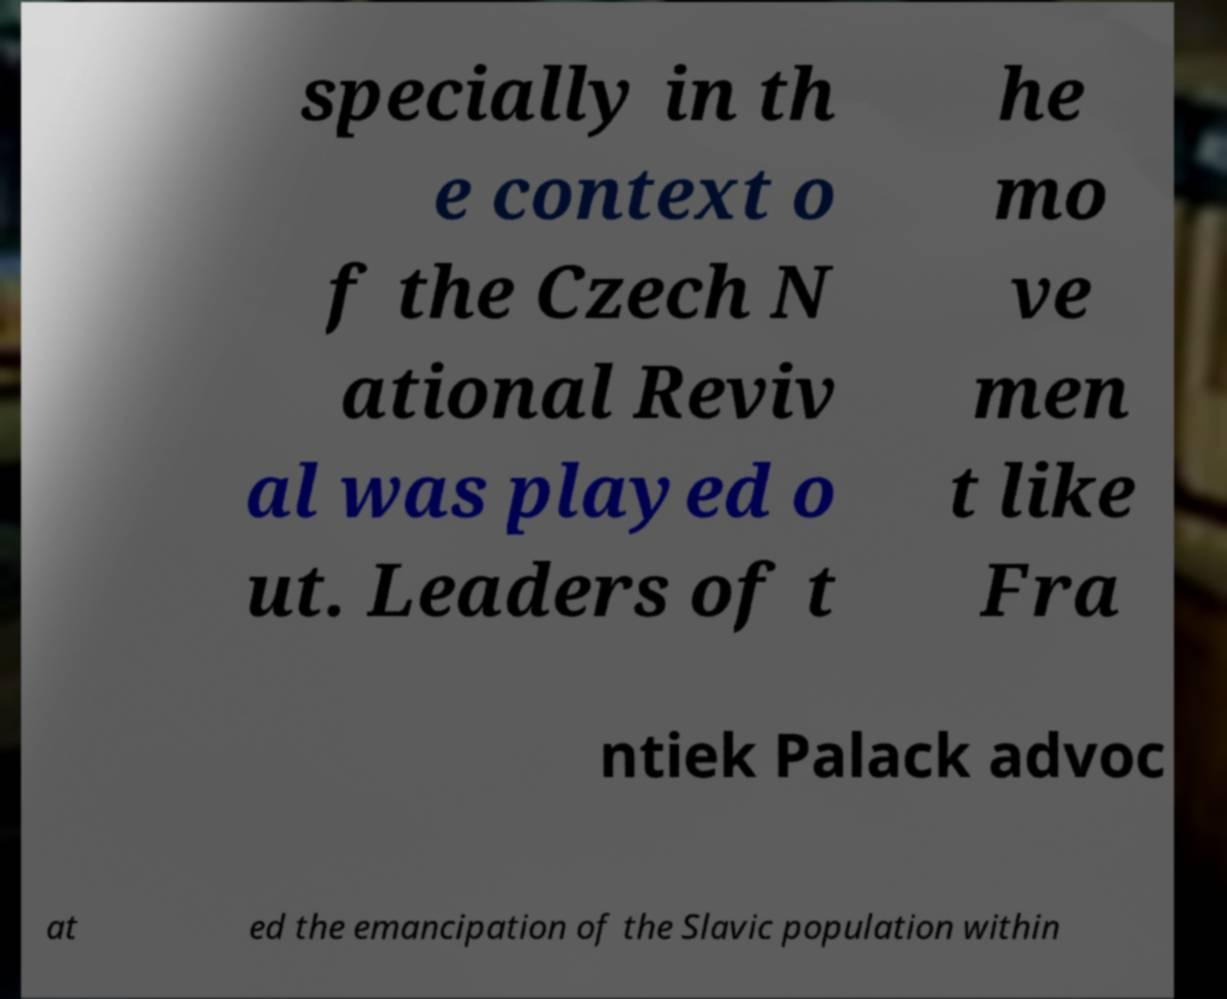I need the written content from this picture converted into text. Can you do that? specially in th e context o f the Czech N ational Reviv al was played o ut. Leaders of t he mo ve men t like Fra ntiek Palack advoc at ed the emancipation of the Slavic population within 